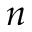Convert formula to latex. <formula><loc_0><loc_0><loc_500><loc_500>n</formula> 